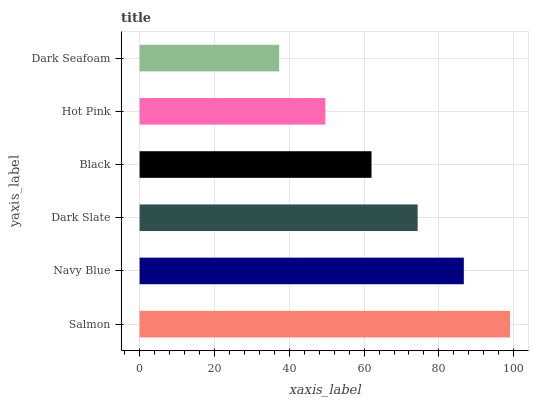Is Dark Seafoam the minimum?
Answer yes or no. Yes. Is Salmon the maximum?
Answer yes or no. Yes. Is Navy Blue the minimum?
Answer yes or no. No. Is Navy Blue the maximum?
Answer yes or no. No. Is Salmon greater than Navy Blue?
Answer yes or no. Yes. Is Navy Blue less than Salmon?
Answer yes or no. Yes. Is Navy Blue greater than Salmon?
Answer yes or no. No. Is Salmon less than Navy Blue?
Answer yes or no. No. Is Dark Slate the high median?
Answer yes or no. Yes. Is Black the low median?
Answer yes or no. Yes. Is Salmon the high median?
Answer yes or no. No. Is Salmon the low median?
Answer yes or no. No. 